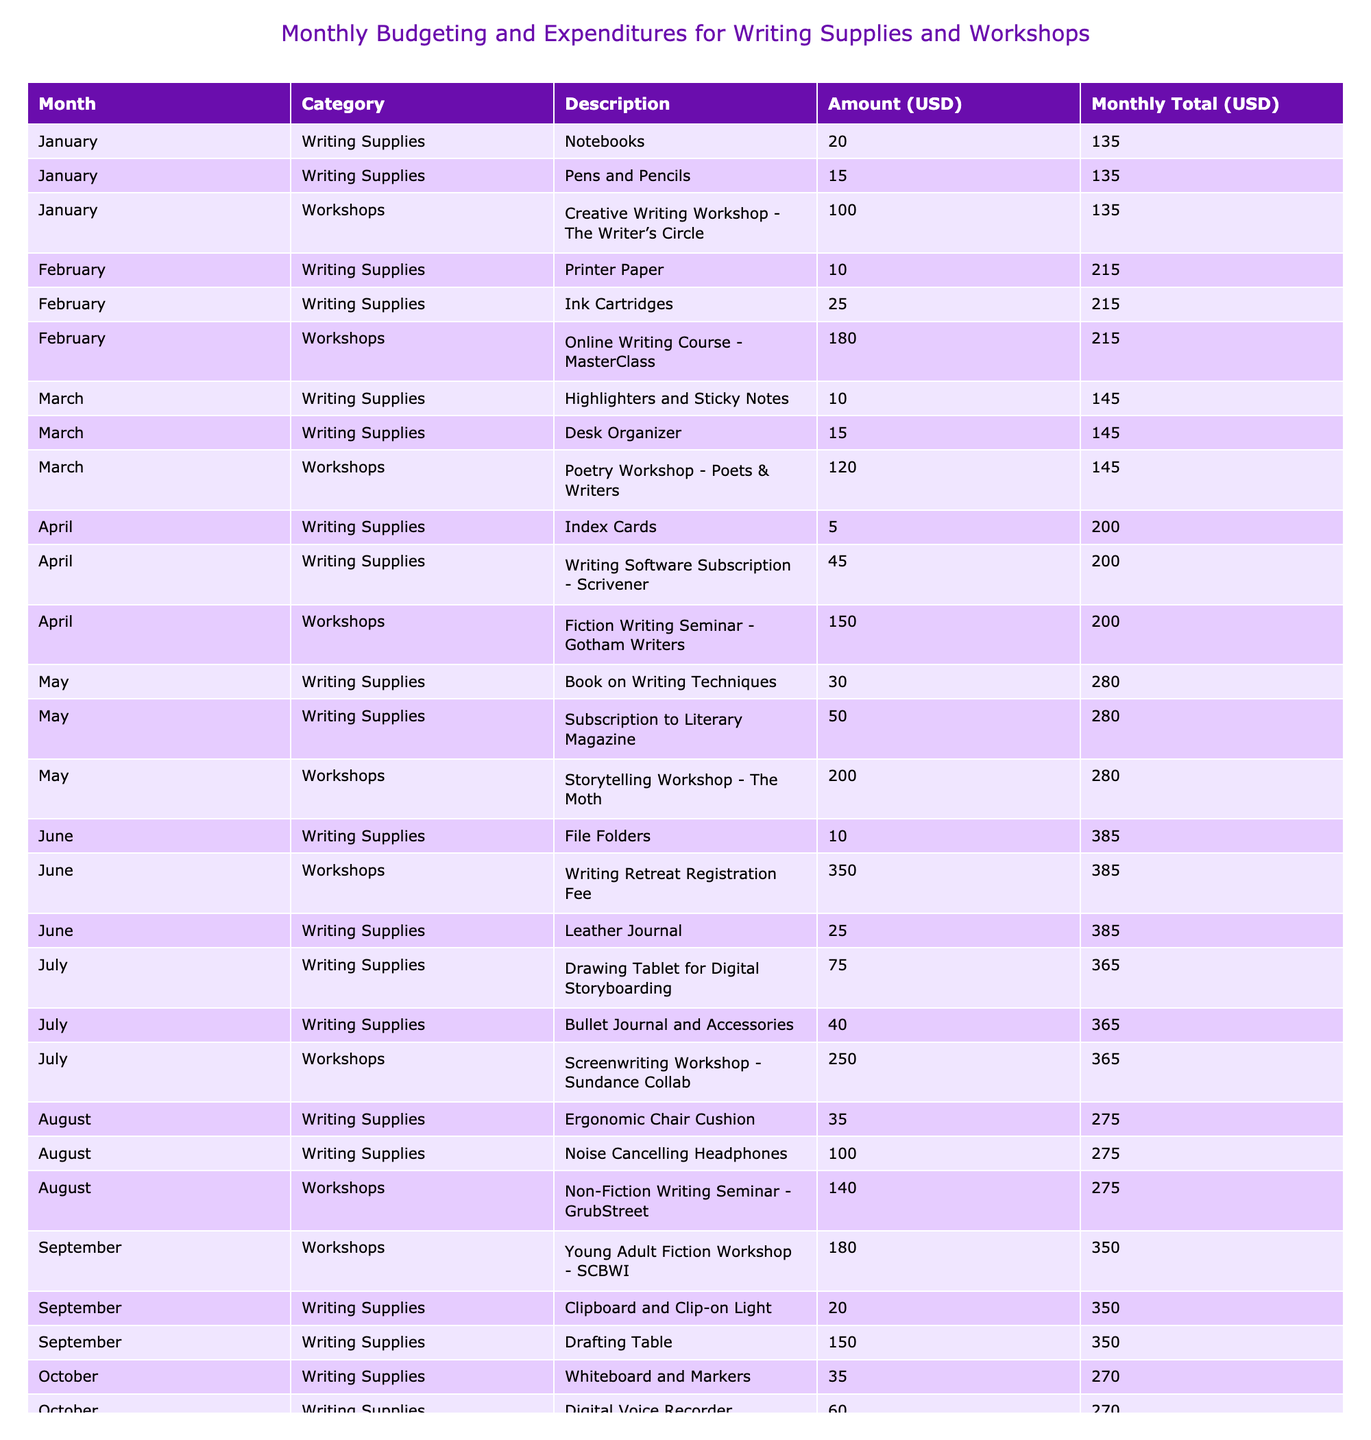What is the total expenditure on writing workshops in July? The table lists the workshops in July with their amounts: Screenwriting Workshop - Sundance Collab for 250 USD. Therefore, the total expenditure on writing workshops in July is simply 250 USD.
Answer: 250 What was the most expensive writing supply purchased in August? In August, the table lists the following writing supplies: Ergonomic Chair Cushion for 35 USD and Noise Cancelling Headphones for 100 USD. The most expensive item is the Noise Cancelling Headphones at 100 USD.
Answer: Noise Cancelling Headphones How much did you spend on writing supplies in April and May combined? For April, the total writing supplies expenditures are Index Cards (5 USD) and Writing Software Subscription - Scrivener (45 USD), totaling 50 USD. In May, the expenditures are Book on Writing Techniques (30 USD) and Subscription to Literary Magazine (50 USD), totaling 80 USD. Adding these together results in 50 + 80 = 130 USD.
Answer: 130 Did you spend more on writing workshops or writing supplies in September? In September, the workshops cost 180 USD (Young Adult Fiction Workshop - SCBWI) while the writing supplies cost are Clipboard and Clip-on Light (20 USD) and Drafting Table (150 USD), totaling 170 USD. Since 170 USD (supplies) is less than 180 USD (workshops), the answer is that workshops cost more.
Answer: Yes What is the average expenditure per month on writing supplies across the year? The total amount spent on writing supplies across all months can be summarized by adding each monthly total from the writing supplies category: January (35), February (35), March (25), April (50), May (80), June (35), July (115), August (135), September (170), October (95), November (60), December (45), totaling 1300 USD. Dividing this by the 12 months gives an average of 1300/12 ≈ 108.33 USD.
Answer: 108.33 Which month had the highest total expenditure? To find the month with the highest total expenditure, we need to sum the amounts for each month. For example, July totals 365 USD (writing supplies + workshops), while other months don't exceed that. Thus, July has the highest total expenditure.
Answer: July How much was spent on writing supplies in the second half of the year (July to December)? The writing supplies expenditures from July to December are: July (115 USD), August (135 USD), September (170 USD), October (95 USD), November (60 USD), December (45 USD). Summing these gives 115 + 135 + 170 + 95 + 60 + 45 = 620 USD.
Answer: 620 Was there any month where the combined total for workshops was greater than 300 USD? On examining the workshop expenses, June has the writing retreat registration fee for 350 USD, which is greater than 300 USD. Therefore, yes, June is the month where the combined total for workshops exceeds 300 USD.
Answer: Yes 